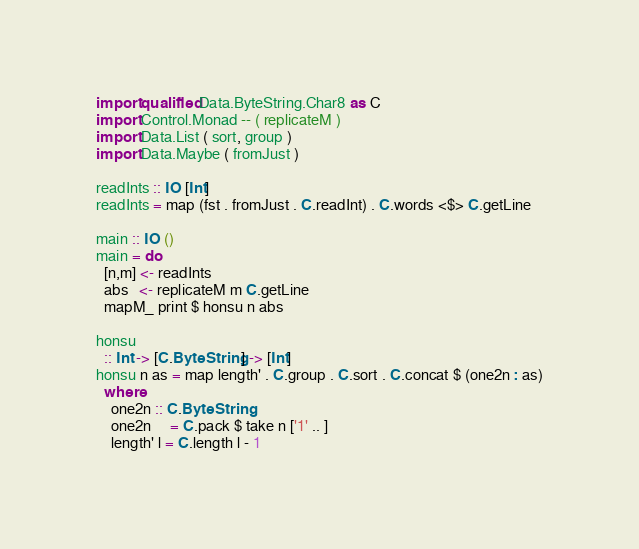<code> <loc_0><loc_0><loc_500><loc_500><_Haskell_>import qualified Data.ByteString.Char8 as C
import Control.Monad -- ( replicateM )
import Data.List ( sort, group )
import Data.Maybe ( fromJust )

readInts :: IO [Int]
readInts = map (fst . fromJust . C.readInt) . C.words <$> C.getLine

main :: IO ()
main = do
  [n,m] <- readInts
  abs   <- replicateM m C.getLine
  mapM_ print $ honsu n abs

honsu
  :: Int -> [C.ByteString] -> [Int]
honsu n as = map length' . C.group . C.sort . C.concat $ (one2n : as)
  where
    one2n :: C.ByteString
    one2n     = C.pack $ take n ['1' .. ] 
    length' l = C.length l - 1</code> 